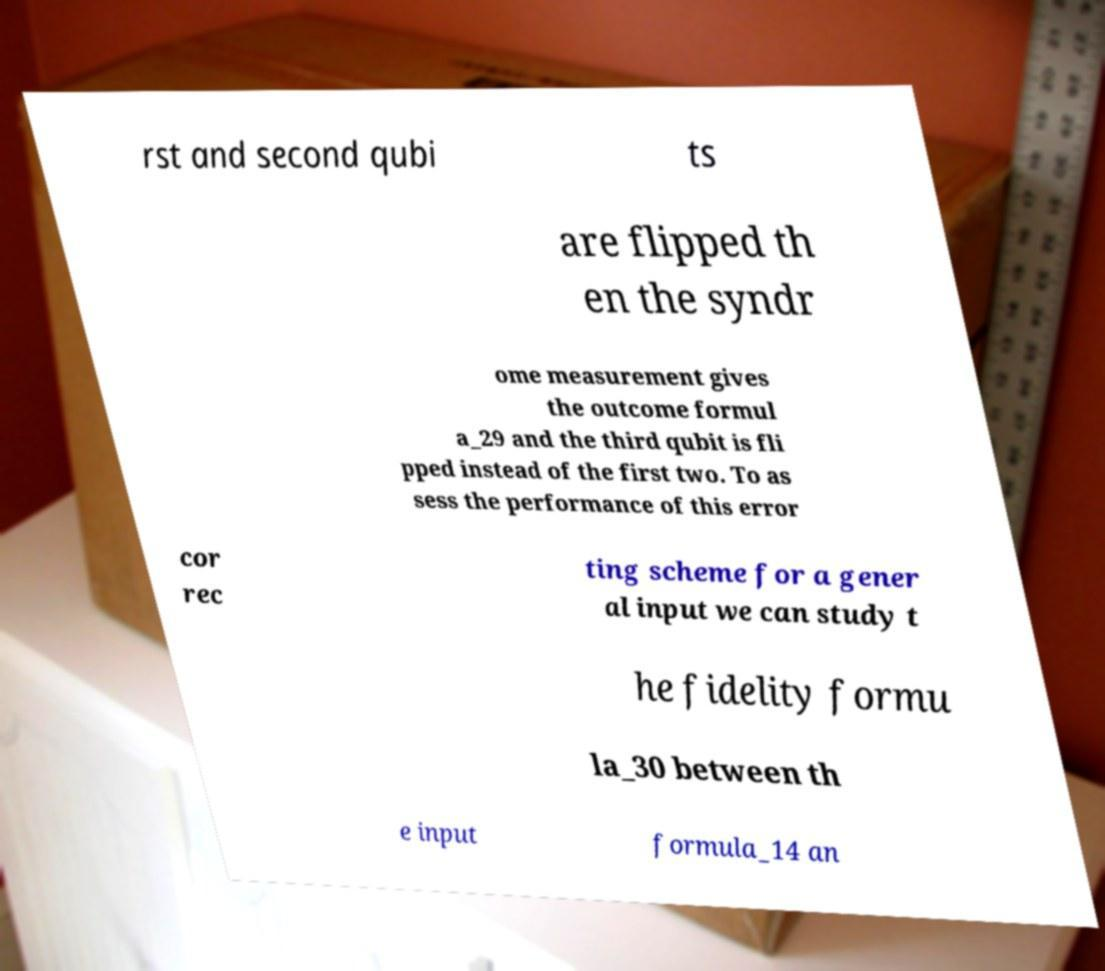For documentation purposes, I need the text within this image transcribed. Could you provide that? rst and second qubi ts are flipped th en the syndr ome measurement gives the outcome formul a_29 and the third qubit is fli pped instead of the first two. To as sess the performance of this error cor rec ting scheme for a gener al input we can study t he fidelity formu la_30 between th e input formula_14 an 